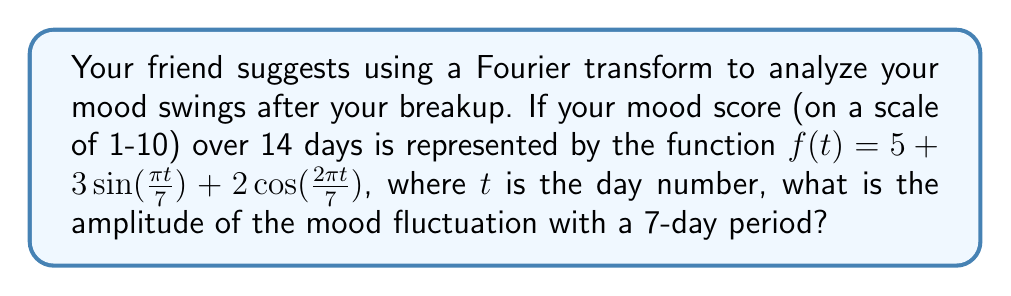Show me your answer to this math problem. Let's approach this step-by-step:

1) The Fourier transform helps us identify the amplitude and frequency of different periodic components in a signal. In this case, our signal is your mood over time.

2) The given function is already in the form of a Fourier series:

   $f(t) = 5 + 3\sin(\frac{\pi t}{7}) + 2\cos(\frac{2\pi t}{7})$

3) We can identify three components:
   - A constant term: 5
   - A sine term: $3\sin(\frac{\pi t}{7})$
   - A cosine term: $2\cos(\frac{2\pi t}{7})$

4) The period of a function is given by $T = \frac{2\pi}{\omega}$, where $\omega$ is the angular frequency.

5) For the sine term:
   $\frac{\pi t}{7} = \omega t$, so $\omega = \frac{\pi}{7}$
   Therefore, $T = \frac{2\pi}{\frac{\pi}{7}} = 14$ days

6) For the cosine term:
   $\frac{2\pi t}{7} = \omega t$, so $\omega = \frac{2\pi}{7}$
   Therefore, $T = \frac{2\pi}{\frac{2\pi}{7}} = 7$ days

7) The question asks for the amplitude of the 7-day period fluctuation, which corresponds to the cosine term.

8) The amplitude of a cosine term $A\cos(\omega t)$ is simply $|A|$.

Therefore, the amplitude of the 7-day period fluctuation is 2.
Answer: 2 